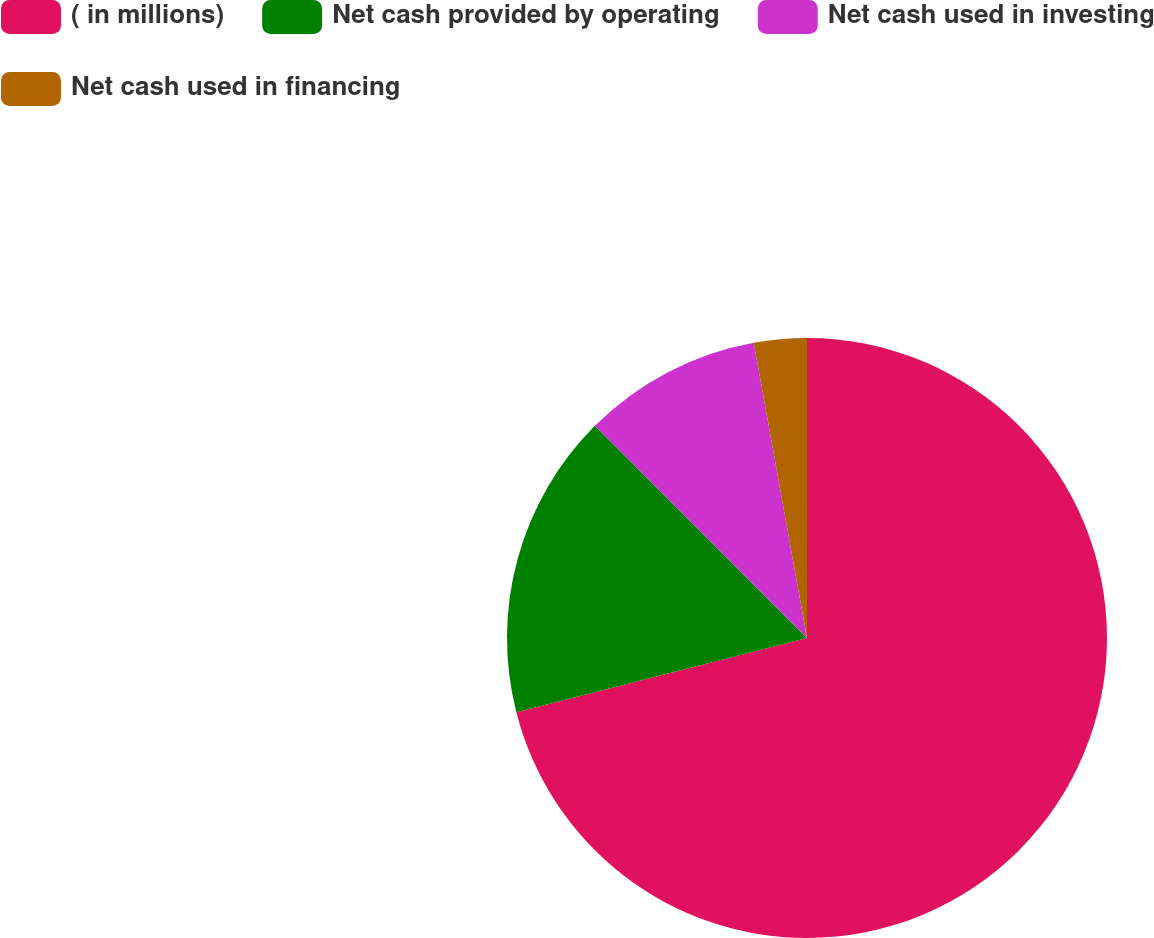Convert chart to OTSL. <chart><loc_0><loc_0><loc_500><loc_500><pie_chart><fcel>( in millions)<fcel>Net cash provided by operating<fcel>Net cash used in investing<fcel>Net cash used in financing<nl><fcel>71.02%<fcel>16.48%<fcel>9.66%<fcel>2.84%<nl></chart> 